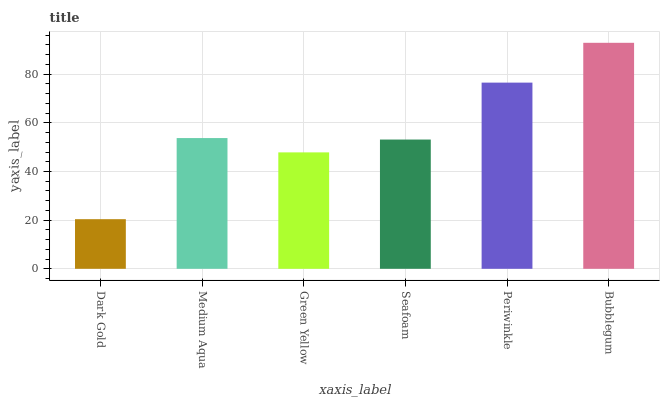Is Dark Gold the minimum?
Answer yes or no. Yes. Is Bubblegum the maximum?
Answer yes or no. Yes. Is Medium Aqua the minimum?
Answer yes or no. No. Is Medium Aqua the maximum?
Answer yes or no. No. Is Medium Aqua greater than Dark Gold?
Answer yes or no. Yes. Is Dark Gold less than Medium Aqua?
Answer yes or no. Yes. Is Dark Gold greater than Medium Aqua?
Answer yes or no. No. Is Medium Aqua less than Dark Gold?
Answer yes or no. No. Is Medium Aqua the high median?
Answer yes or no. Yes. Is Seafoam the low median?
Answer yes or no. Yes. Is Periwinkle the high median?
Answer yes or no. No. Is Periwinkle the low median?
Answer yes or no. No. 